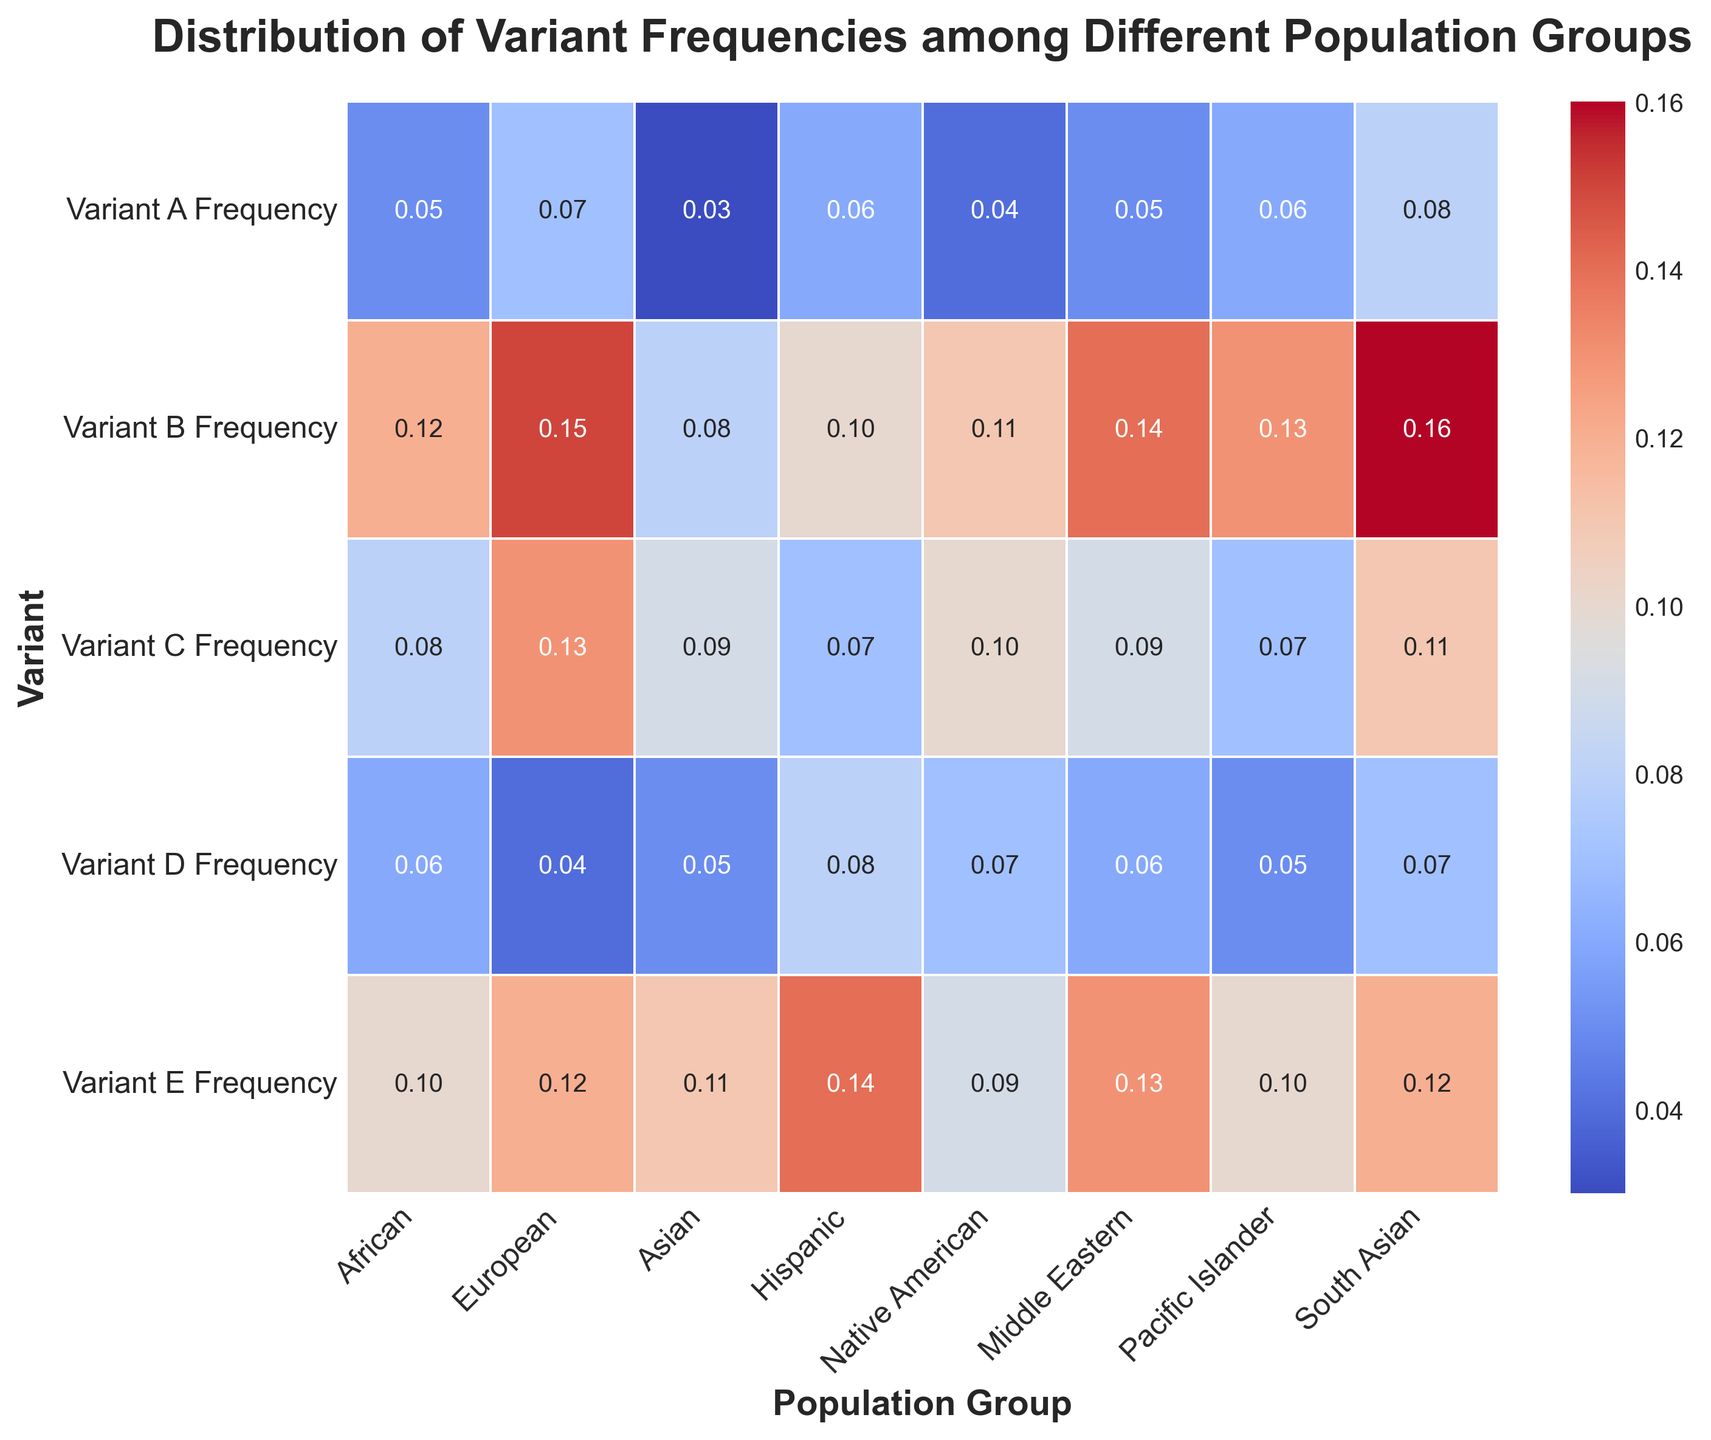Which population group has the highest frequency for Variant C? To find the population group with the highest frequency for Variant C, locate the column for Variant C and look for the highest value. The highest value is 0.13, which corresponds to the European population group.
Answer: European What is the average frequency of Variant A across all population groups? To determine the average frequency of Variant A, sum the frequencies for Variant A across all population groups and then divide by the number of groups. The sum is 0.05 + 0.07 + 0.03 + 0.06 + 0.04 + 0.05 + 0.06 + 0.08 = 0.44. The average is 0.44 / 8 = 0.055.
Answer: 0.055 Which variants appear to have relatively similar frequencies across most population groups based on the color intensity? Variants with relatively similar frequencies will appear with similar color intensities across the rows. From the heatmap, we notice that the color intensity for Variant C and Variant D is relatively uniform across most population groups, indicating similar frequencies.
Answer: Variant C and Variant D Calculate the frequency difference of Variant E between South Asian and Hispanic populations. Locate the frequencies of Variant E for South Asian (0.12) and Hispanic (0.14). Subtract the South Asian value from the Hispanic value: 0.14 - 0.12 = 0.02.
Answer: 0.02 Which population group has the lowest combined frequency for Variants B and D? Add the frequencies of Variants B and D for each population group, then compare the sums to find the lowest one. The sums are African: 0.12 + 0.06 = 0.18, European: 0.15 + 0.04 = 0.19, Asian: 0.08 + 0.05 = 0.13, Hispanic: 0.10 + 0.08 = 0.18, Native American: 0.11 + 0.07 = 0.18, Middle Eastern: 0.14 + 0.06 = 0.20, Pacific Islander: 0.13 + 0.05 = 0.18, South Asian: 0.16 + 0.07 = 0.23. The lowest sum is for the Asian population.
Answer: Asian Identify which variant has the largest range in frequency across all population groups. Calculate the range (maximum - minimum) for each variant across all population groups. The ranges are: Variant A: 0.08 - 0.03 = 0.05; Variant B: 0.16 - 0.08 = 0.08; Variant C: 0.13 - 0.07 = 0.06; Variant D: 0.08 - 0.04 = 0.04; Variant E: 0.14 - 0.09 = 0.05. The largest range is for Variant B with a range of 0.08.
Answer: Variant B What is the combined frequency of all variants for the African population? Sum the frequencies of all variants for the African population. The total is 0.05 + 0.12 + 0.08 + 0.06 + 0.10 = 0.41.
Answer: 0.41 